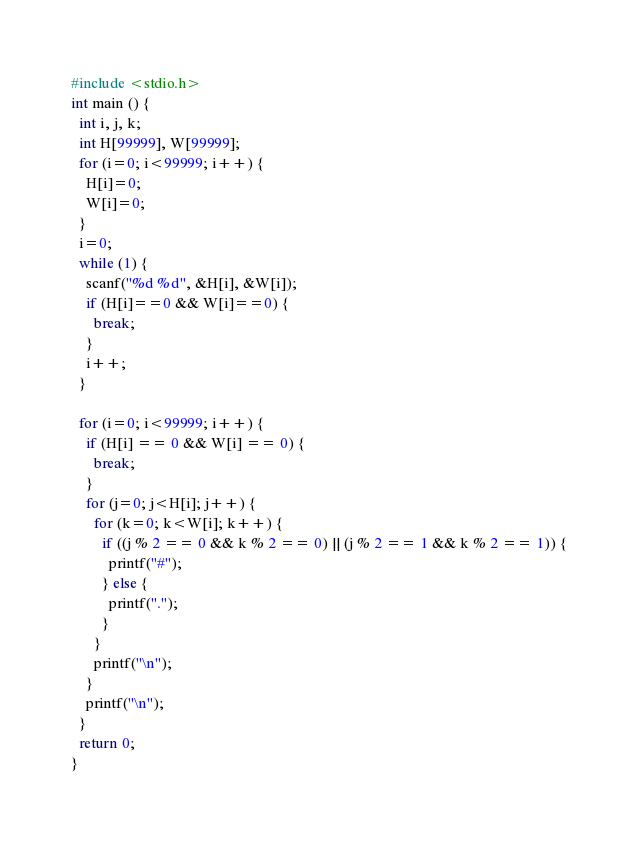Convert code to text. <code><loc_0><loc_0><loc_500><loc_500><_C_>#include <stdio.h>
int main () {
  int i, j, k;
  int H[99999], W[99999];
  for (i=0; i<99999; i++) {
    H[i]=0;
    W[i]=0;
  }
  i=0;
  while (1) {
    scanf("%d %d", &H[i], &W[i]);
    if (H[i]==0 && W[i]==0) {
      break;
    }
    i++;
  }
 
  for (i=0; i<99999; i++) {
    if (H[i] == 0 && W[i] == 0) {
      break;
    }
    for (j=0; j<H[i]; j++) {
      for (k=0; k<W[i]; k++) {
        if ((j % 2 == 0 && k % 2 == 0) || (j % 2 == 1 && k % 2 == 1)) {
          printf("#");
        } else {
          printf(".");
        }
      }
      printf("\n");
    }
    printf("\n");
  }
  return 0;
}</code> 